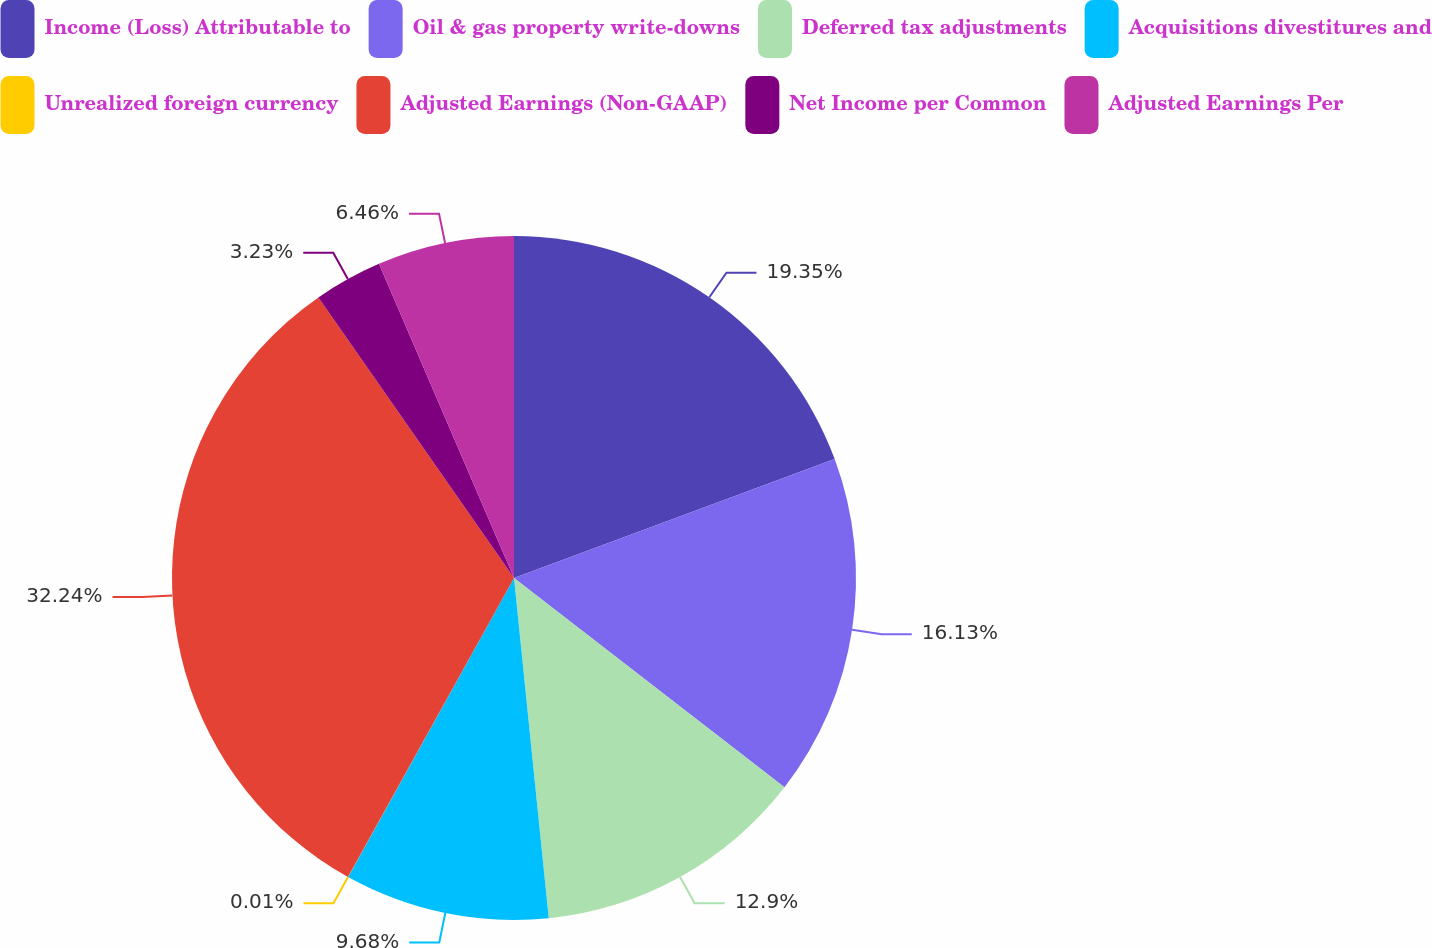Convert chart. <chart><loc_0><loc_0><loc_500><loc_500><pie_chart><fcel>Income (Loss) Attributable to<fcel>Oil & gas property write-downs<fcel>Deferred tax adjustments<fcel>Acquisitions divestitures and<fcel>Unrealized foreign currency<fcel>Adjusted Earnings (Non-GAAP)<fcel>Net Income per Common<fcel>Adjusted Earnings Per<nl><fcel>19.35%<fcel>16.13%<fcel>12.9%<fcel>9.68%<fcel>0.01%<fcel>32.24%<fcel>3.23%<fcel>6.46%<nl></chart> 